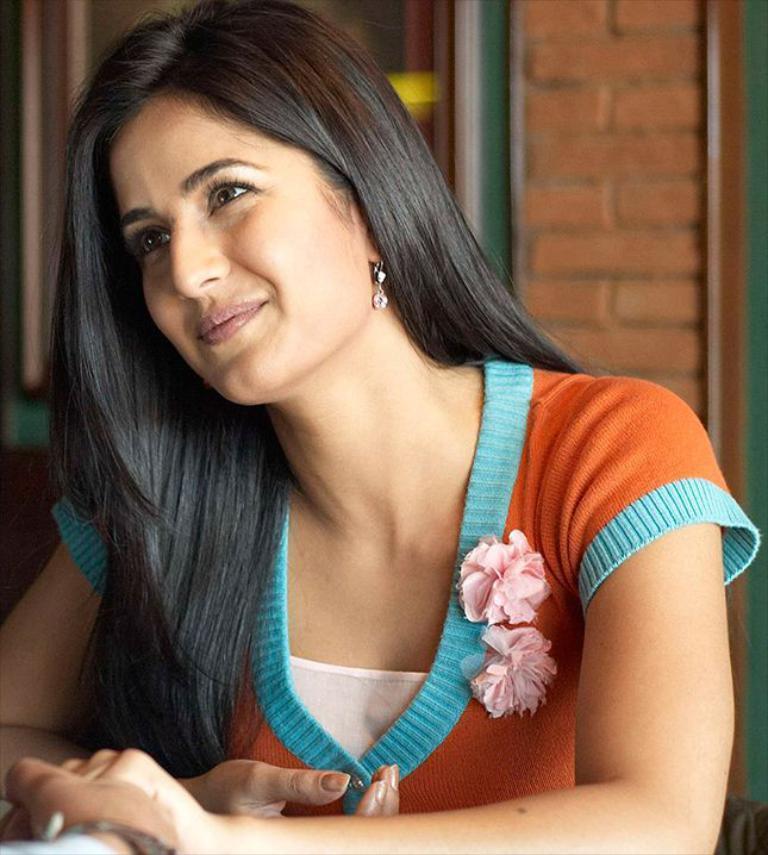Could you give a brief overview of what you see in this image? In this image a woman is sitting. She is smiling. In the bottom we can see another hand. In the background there is wall, window, curtain. 